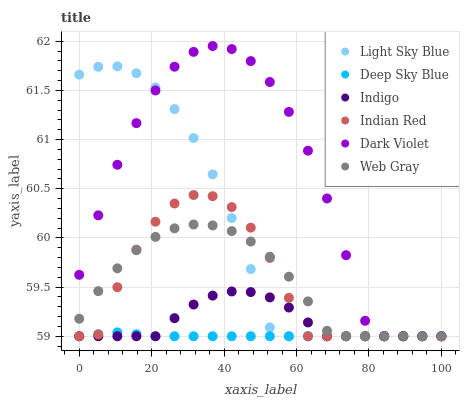Does Deep Sky Blue have the minimum area under the curve?
Answer yes or no. Yes. Does Dark Violet have the maximum area under the curve?
Answer yes or no. Yes. Does Indigo have the minimum area under the curve?
Answer yes or no. No. Does Indigo have the maximum area under the curve?
Answer yes or no. No. Is Deep Sky Blue the smoothest?
Answer yes or no. Yes. Is Dark Violet the roughest?
Answer yes or no. Yes. Is Indigo the smoothest?
Answer yes or no. No. Is Indigo the roughest?
Answer yes or no. No. Does Web Gray have the lowest value?
Answer yes or no. Yes. Does Dark Violet have the highest value?
Answer yes or no. Yes. Does Indigo have the highest value?
Answer yes or no. No. Does Dark Violet intersect Light Sky Blue?
Answer yes or no. Yes. Is Dark Violet less than Light Sky Blue?
Answer yes or no. No. Is Dark Violet greater than Light Sky Blue?
Answer yes or no. No. 